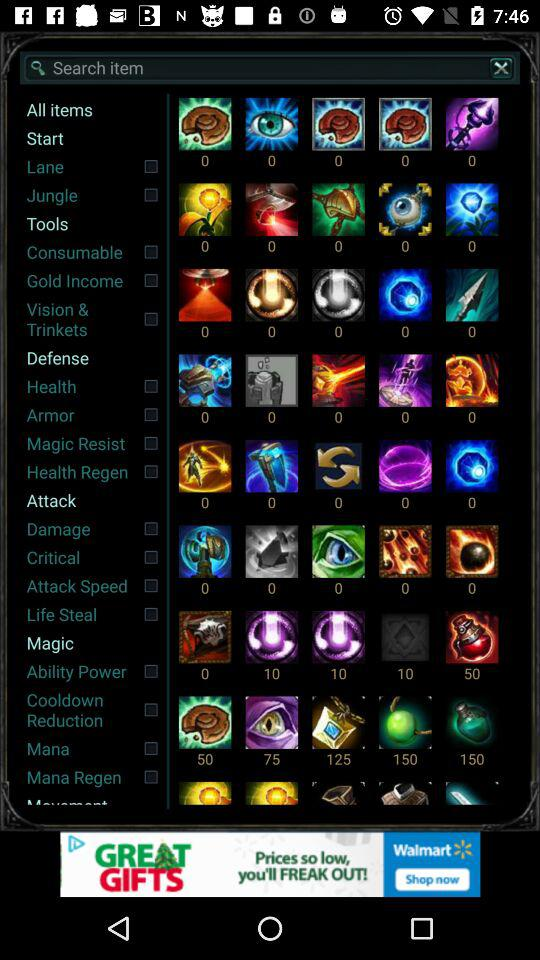What is the status of "Health"? The status is "off". 